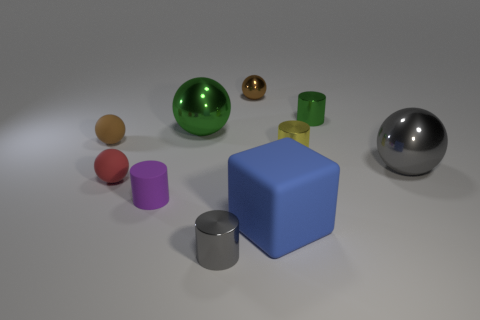What is the shape of the tiny purple thing that is made of the same material as the red thing?
Ensure brevity in your answer.  Cylinder. What is the size of the green metallic thing that is the same shape as the tiny gray object?
Make the answer very short. Small. There is another ball that is the same material as the red sphere; what is its size?
Your answer should be very brief. Small. What is the size of the blue rubber cube?
Keep it short and to the point. Large. Is the number of small gray metal things that are behind the small rubber cylinder less than the number of large red things?
Offer a terse response. No. How many objects have the same size as the green ball?
Offer a very short reply. 2. There is a tiny rubber thing that is the same color as the tiny metallic ball; what is its shape?
Provide a short and direct response. Sphere. There is a tiny metallic object that is to the left of the brown metallic object; is it the same color as the shiny ball in front of the yellow metallic object?
Your response must be concise. Yes. What number of green cylinders are on the left side of the big blue rubber cube?
Offer a very short reply. 0. There is a rubber thing that is the same color as the small metallic sphere; what is its size?
Provide a short and direct response. Small. 